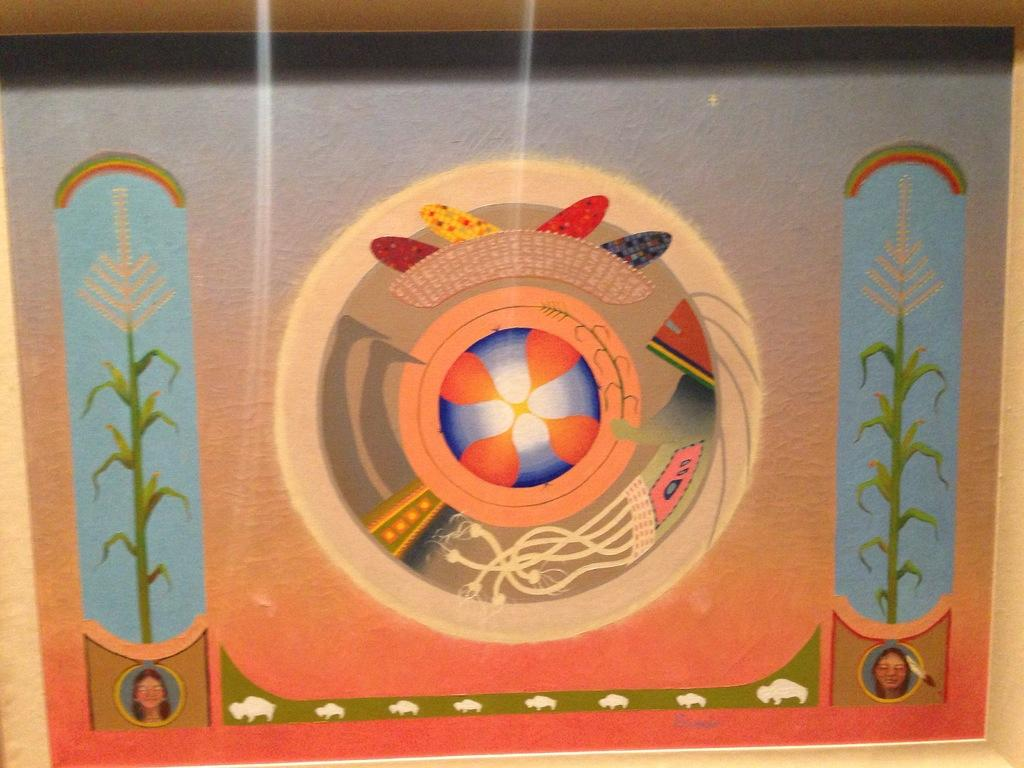What is the main subject in the image? There is a painting in the image. Where is the painting located? The painting is on a wall. How many boats are in the painting? There is no information about boats in the painting or the image, as the facts only mention the presence of a painting on a wall. 